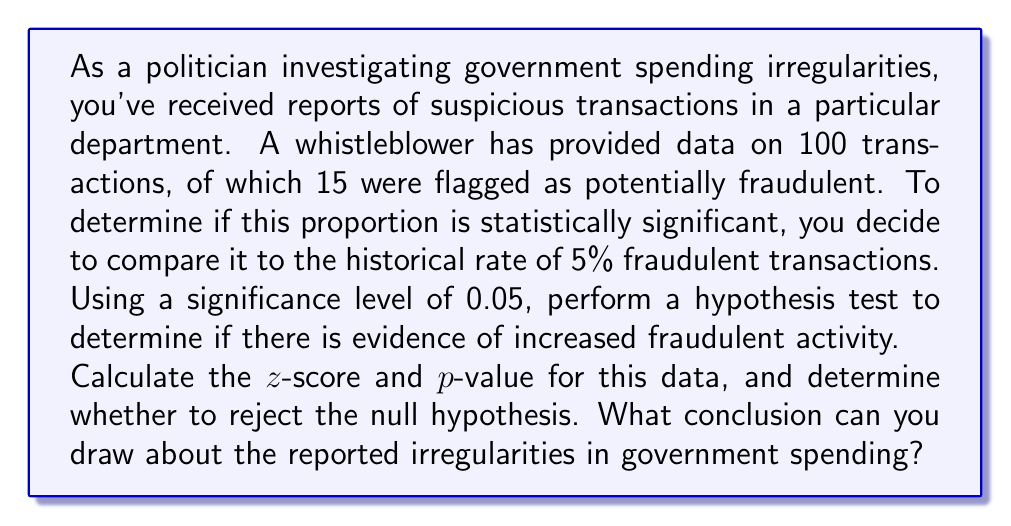Show me your answer to this math problem. To solve this problem, we'll use a one-proportion z-test. We'll follow these steps:

1. State the hypotheses:
   $H_0: p = 0.05$ (null hypothesis)
   $H_a: p > 0.05$ (alternative hypothesis, one-tailed test)

2. Calculate the sample proportion:
   $\hat{p} = \frac{\text{number of successes}}{\text{sample size}} = \frac{15}{100} = 0.15$

3. Calculate the standard error:
   $SE = \sqrt{\frac{p_0(1-p_0)}{n}} = \sqrt{\frac{0.05(1-0.05)}{100}} = 0.0218$

4. Calculate the z-score:
   $$z = \frac{\hat{p} - p_0}{SE} = \frac{0.15 - 0.05}{0.0218} = 4.59$$

5. Find the p-value:
   The p-value is the area to the right of z = 4.59 in the standard normal distribution.
   Using a z-table or calculator, we find:
   p-value $\approx 2.21 \times 10^{-6}$

6. Compare the p-value to the significance level:
   $2.21 \times 10^{-6} < 0.05$

7. Make a decision:
   Since the p-value is less than the significance level, we reject the null hypothesis.
Answer: The z-score is 4.59, and the p-value is approximately $2.21 \times 10^{-6}$. We reject the null hypothesis at the 0.05 significance level. There is strong statistical evidence to support the claim that the proportion of fraudulent transactions is higher than the historical rate of 5%. This suggests that the reported irregularities in government spending are statistically significant and warrant further investigation. 